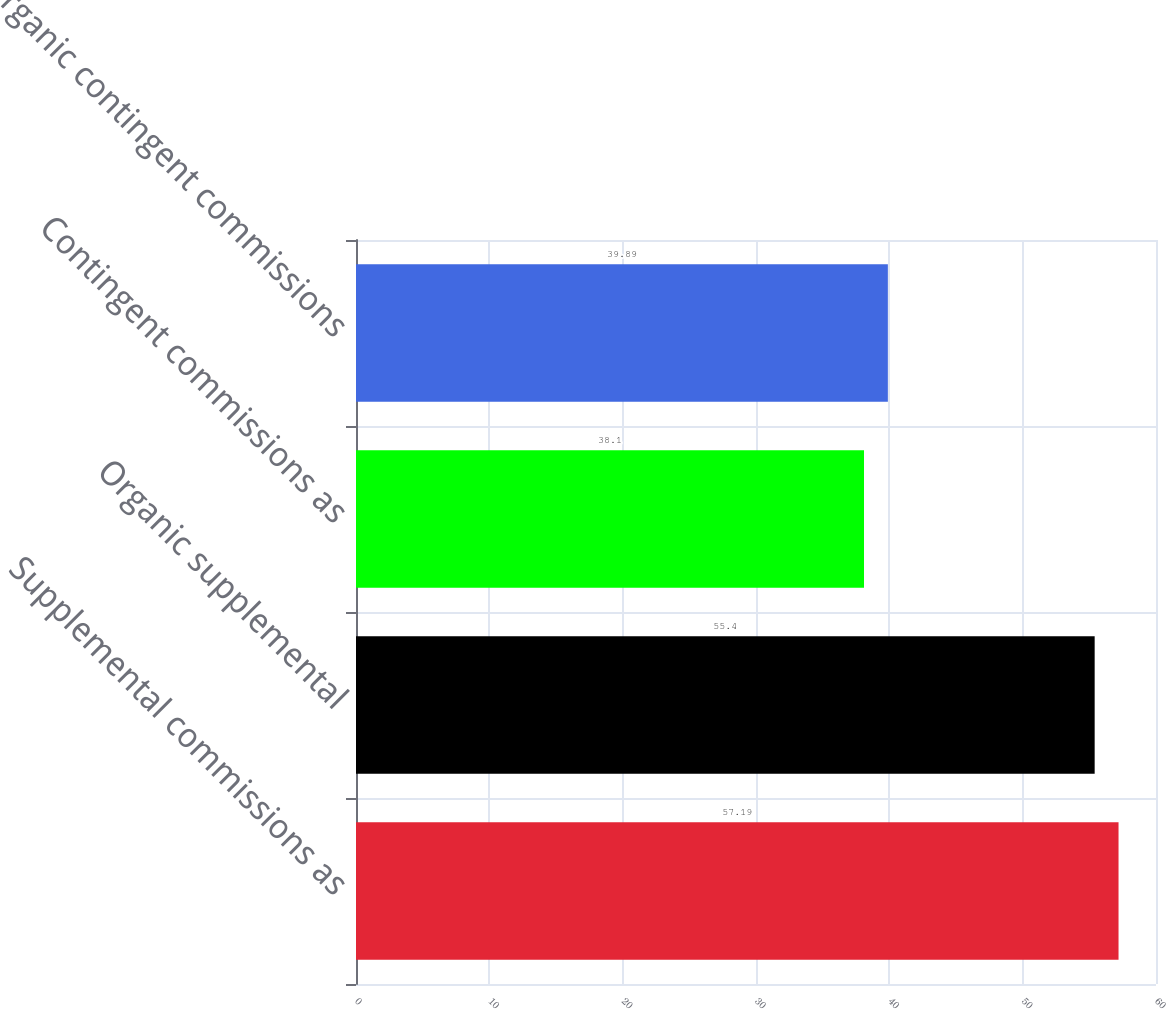Convert chart to OTSL. <chart><loc_0><loc_0><loc_500><loc_500><bar_chart><fcel>Supplemental commissions as<fcel>Organic supplemental<fcel>Contingent commissions as<fcel>Organic contingent commissions<nl><fcel>57.19<fcel>55.4<fcel>38.1<fcel>39.89<nl></chart> 